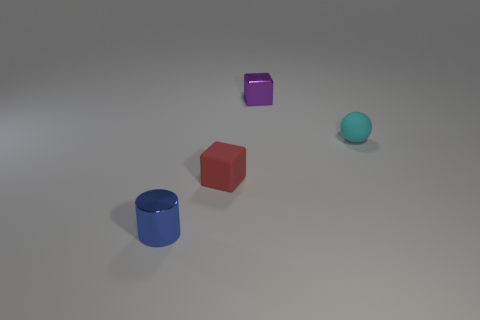Add 3 tiny red shiny spheres. How many objects exist? 7 Subtract all balls. How many objects are left? 3 Add 3 purple shiny objects. How many purple shiny objects exist? 4 Subtract 0 brown cylinders. How many objects are left? 4 Subtract all tiny blue blocks. Subtract all small red matte blocks. How many objects are left? 3 Add 1 tiny red matte things. How many tiny red matte things are left? 2 